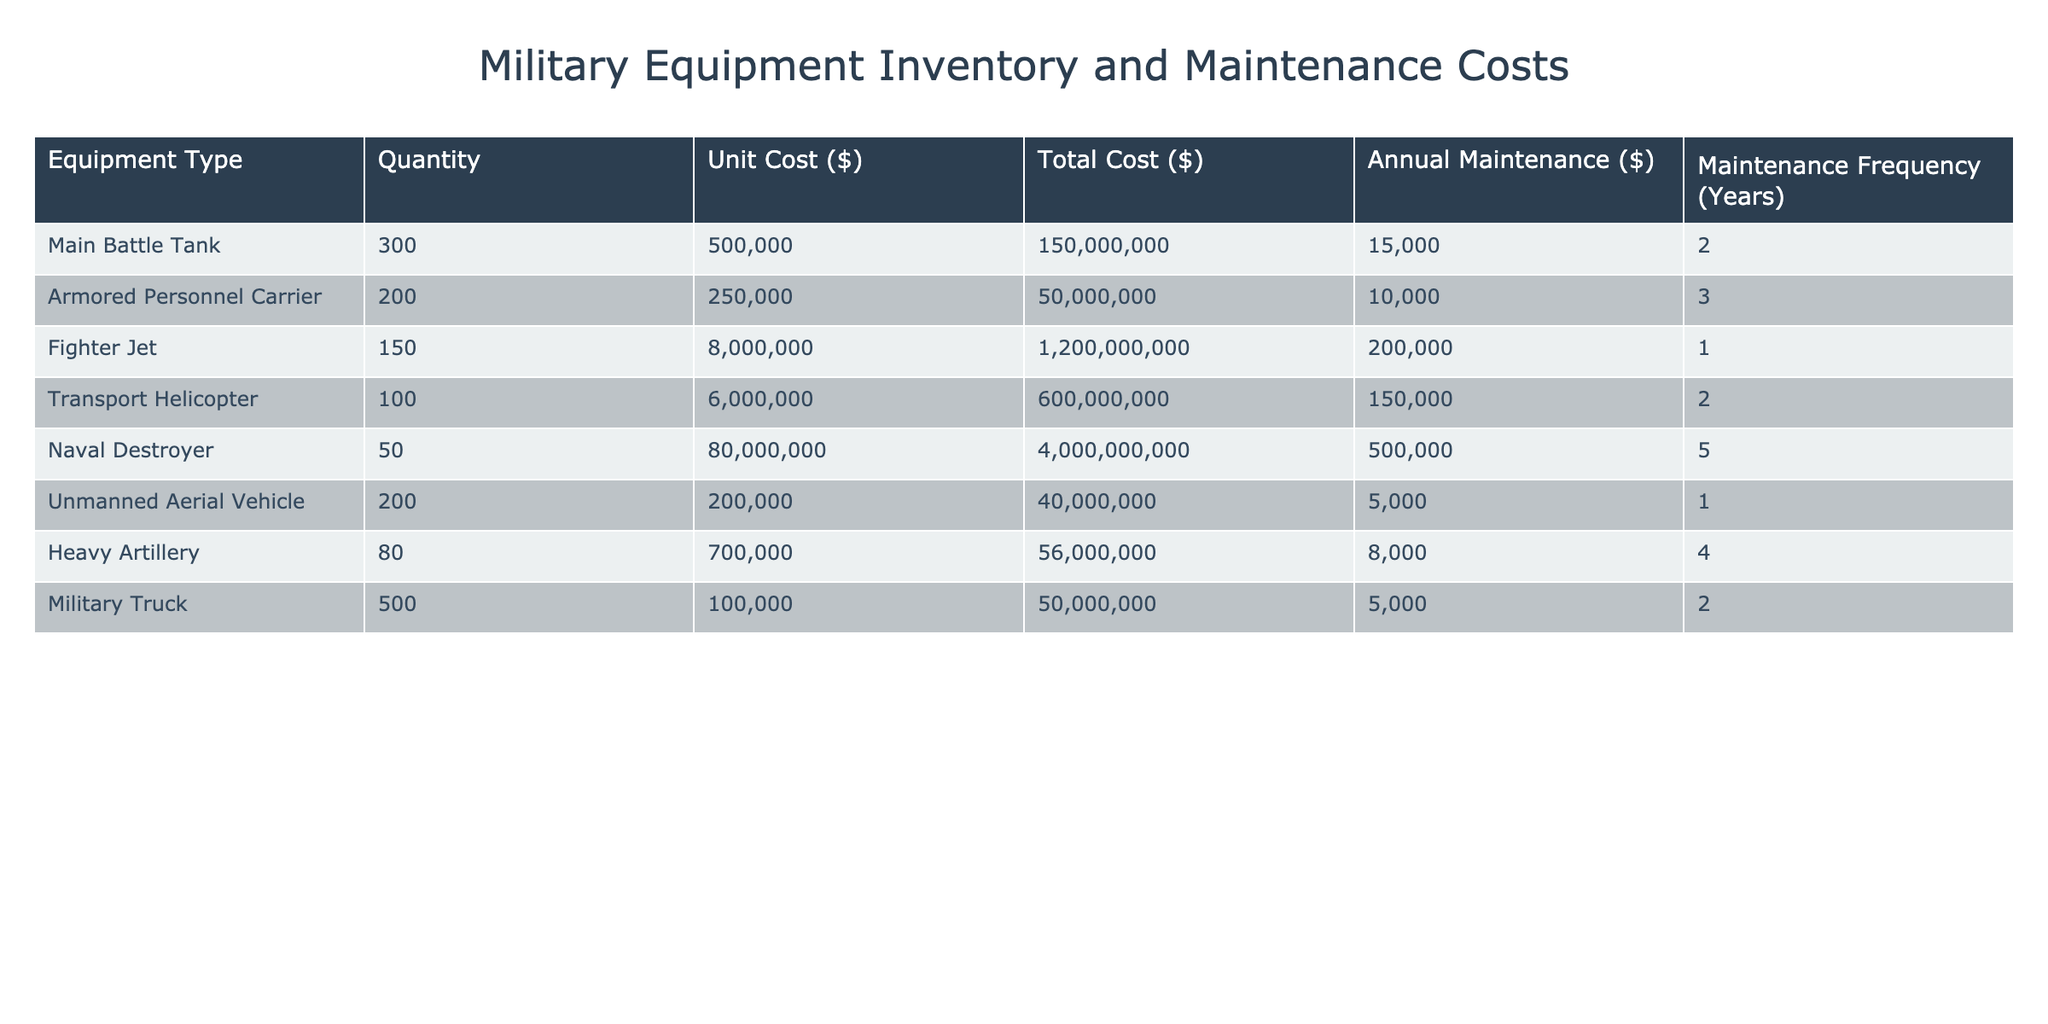What is the total cost of the Main Battle Tanks? The total cost of the Main Battle Tanks is listed in the table under "Total Cost (USD)" for that equipment type, which shows 150000000.
Answer: 150000000 How many Armored Personnel Carriers are in the inventory? The inventory quantity for Armored Personnel Carriers can be directly found in the "Inventory Quantity" column for that row, which is 200.
Answer: 200 What is the annual maintenance cost of the Fighter Jets? The annual maintenance cost for Fighter Jets is specified in the table under "Annual Maintenance Cost (USD)," which shows 200000.
Answer: 200000 Which equipment type has the highest unit cost? To determine the equipment type with the highest unit cost, we compare the "Unit Cost (USD)" column. The Fighter Jet has the highest unit cost at 8000000.
Answer: Fighter Jet What is the total annual maintenance cost for all equipment types? To find the total annual maintenance cost, sum the values in the "Annual Maintenance Cost (USD)" column: 15000 + 10000 + 200000 + 150000 + 500000 + 5000 + 8000 + 5000 = 850000.
Answer: 850000 Do Navy Destroyers have a higher maintenance cost than Transport Helicopters? Comparing the maintenance costs, the annual maintenance cost for Naval Destroyers is 500000 while for Transport Helicopters it is 150000. Thus, it is true that Naval Destroyers have a higher maintenance cost.
Answer: Yes If the quantity of Heavy Artillery were doubled, what would be the new total cost? The current total cost of Heavy Artillery is 56000000. If the quantity is doubled from 80 to 160, the new total cost is calculated as: 160 * 700000 = 112000000.
Answer: 112000000 How many units of equipment have an annual maintenance cost exceeding 100000? Checking the "Annual Maintenance Cost (USD)" column, we see that only the Fighter Jet and Transport Helicopter have values greater than 100000: Fighter Jet (200000) and Transport Helicopter (150000). Thus, there are two units.
Answer: 2 Is the average unit cost of the unarmed aerial vehicles higher than that of the armored personnel carriers? The unit cost for Unmanned Aerial Vehicles is 200000, and for Armored Personnel Carriers, it’s 250000. Since 200000 is lower than 250000, the average unit cost for UAVs is not higher.
Answer: No 